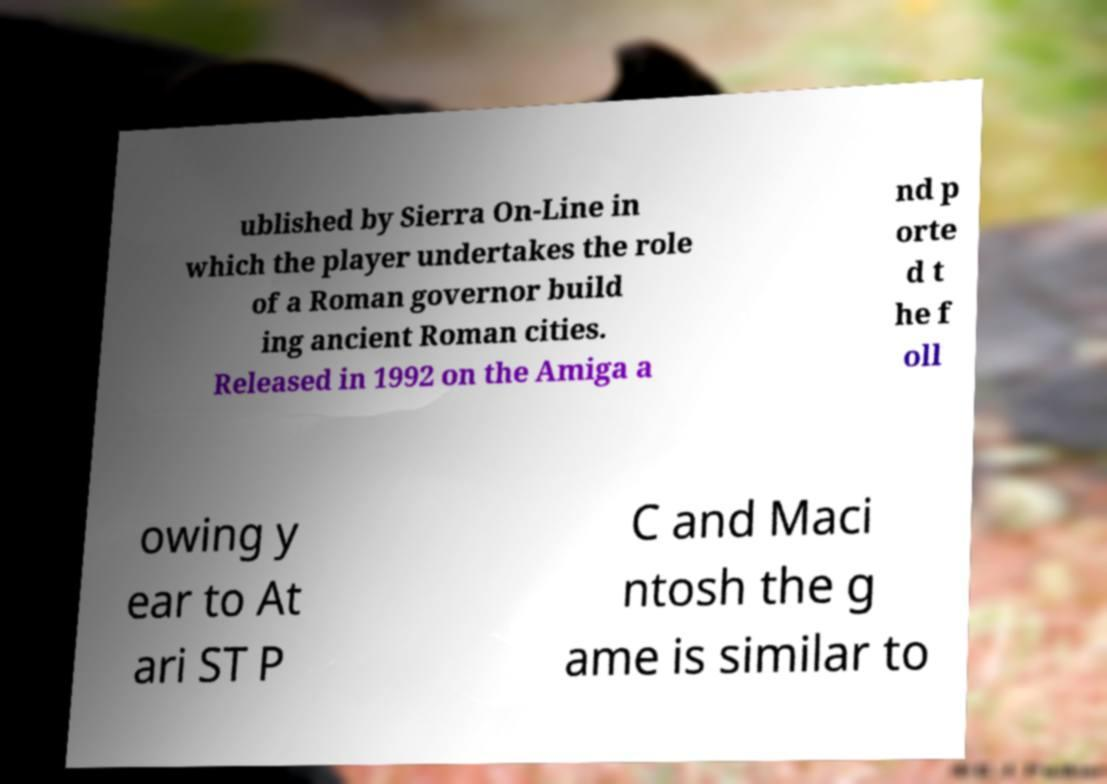Can you accurately transcribe the text from the provided image for me? ublished by Sierra On-Line in which the player undertakes the role of a Roman governor build ing ancient Roman cities. Released in 1992 on the Amiga a nd p orte d t he f oll owing y ear to At ari ST P C and Maci ntosh the g ame is similar to 